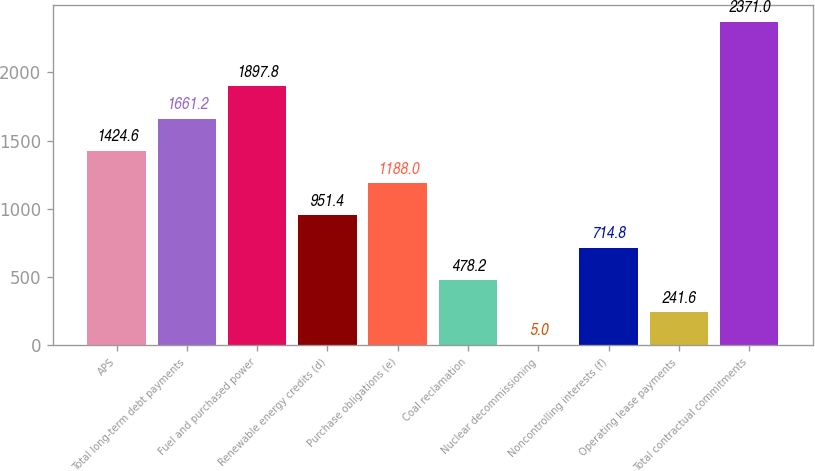<chart> <loc_0><loc_0><loc_500><loc_500><bar_chart><fcel>APS<fcel>Total long-term debt payments<fcel>Fuel and purchased power<fcel>Renewable energy credits (d)<fcel>Purchase obligations (e)<fcel>Coal reclamation<fcel>Nuclear decommissioning<fcel>Noncontrolling interests (f)<fcel>Operating lease payments<fcel>Total contractual commitments<nl><fcel>1424.6<fcel>1661.2<fcel>1897.8<fcel>951.4<fcel>1188<fcel>478.2<fcel>5<fcel>714.8<fcel>241.6<fcel>2371<nl></chart> 